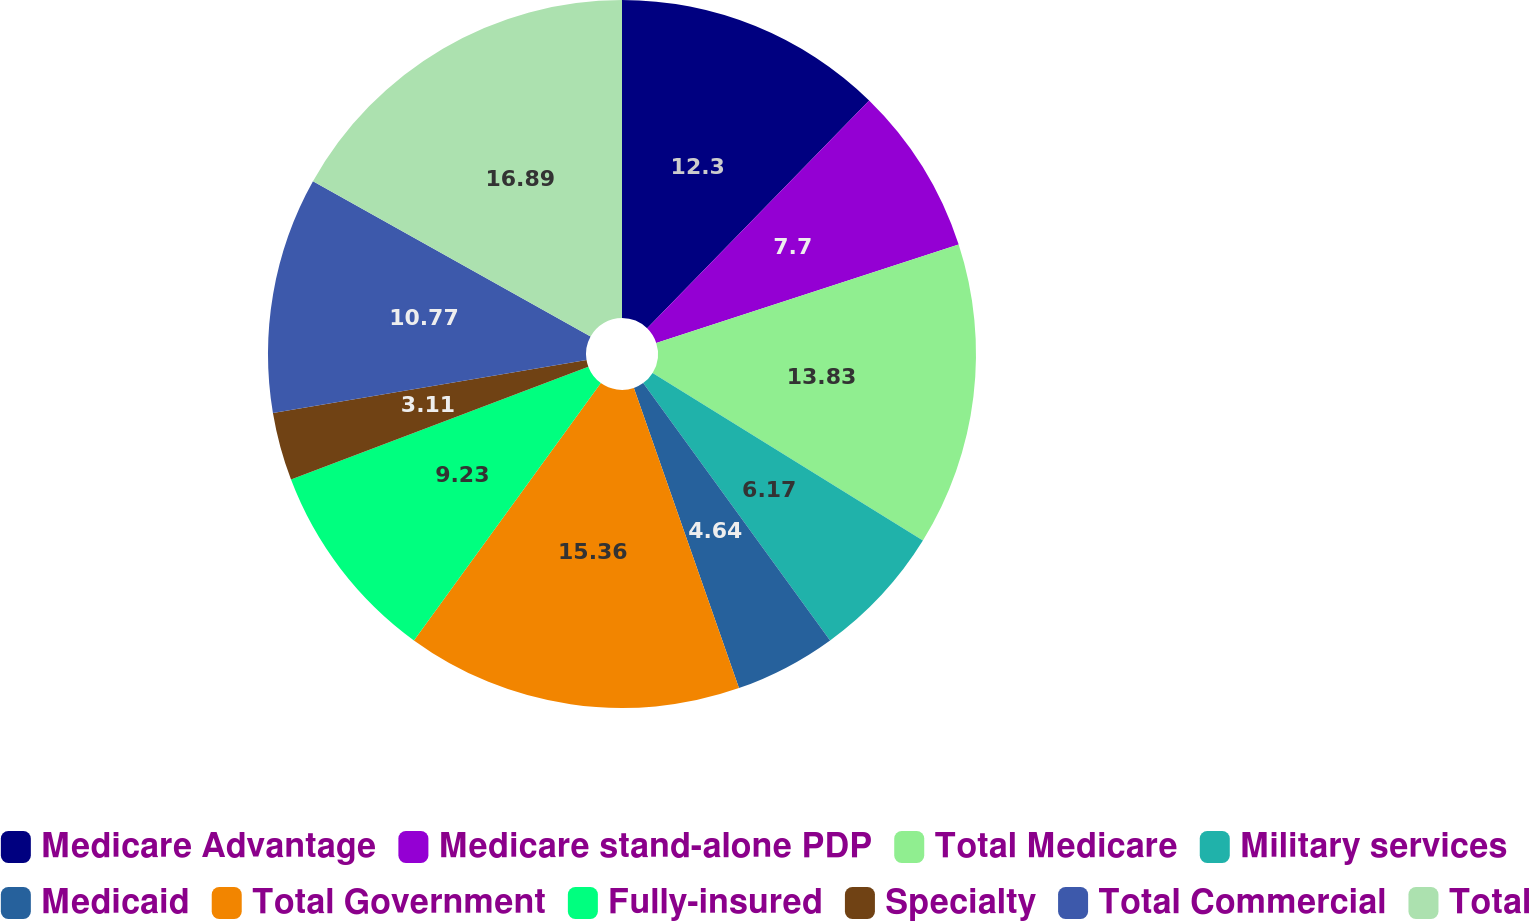Convert chart. <chart><loc_0><loc_0><loc_500><loc_500><pie_chart><fcel>Medicare Advantage<fcel>Medicare stand-alone PDP<fcel>Total Medicare<fcel>Military services<fcel>Medicaid<fcel>Total Government<fcel>Fully-insured<fcel>Specialty<fcel>Total Commercial<fcel>Total<nl><fcel>12.3%<fcel>7.7%<fcel>13.83%<fcel>6.17%<fcel>4.64%<fcel>15.36%<fcel>9.23%<fcel>3.11%<fcel>10.77%<fcel>16.89%<nl></chart> 